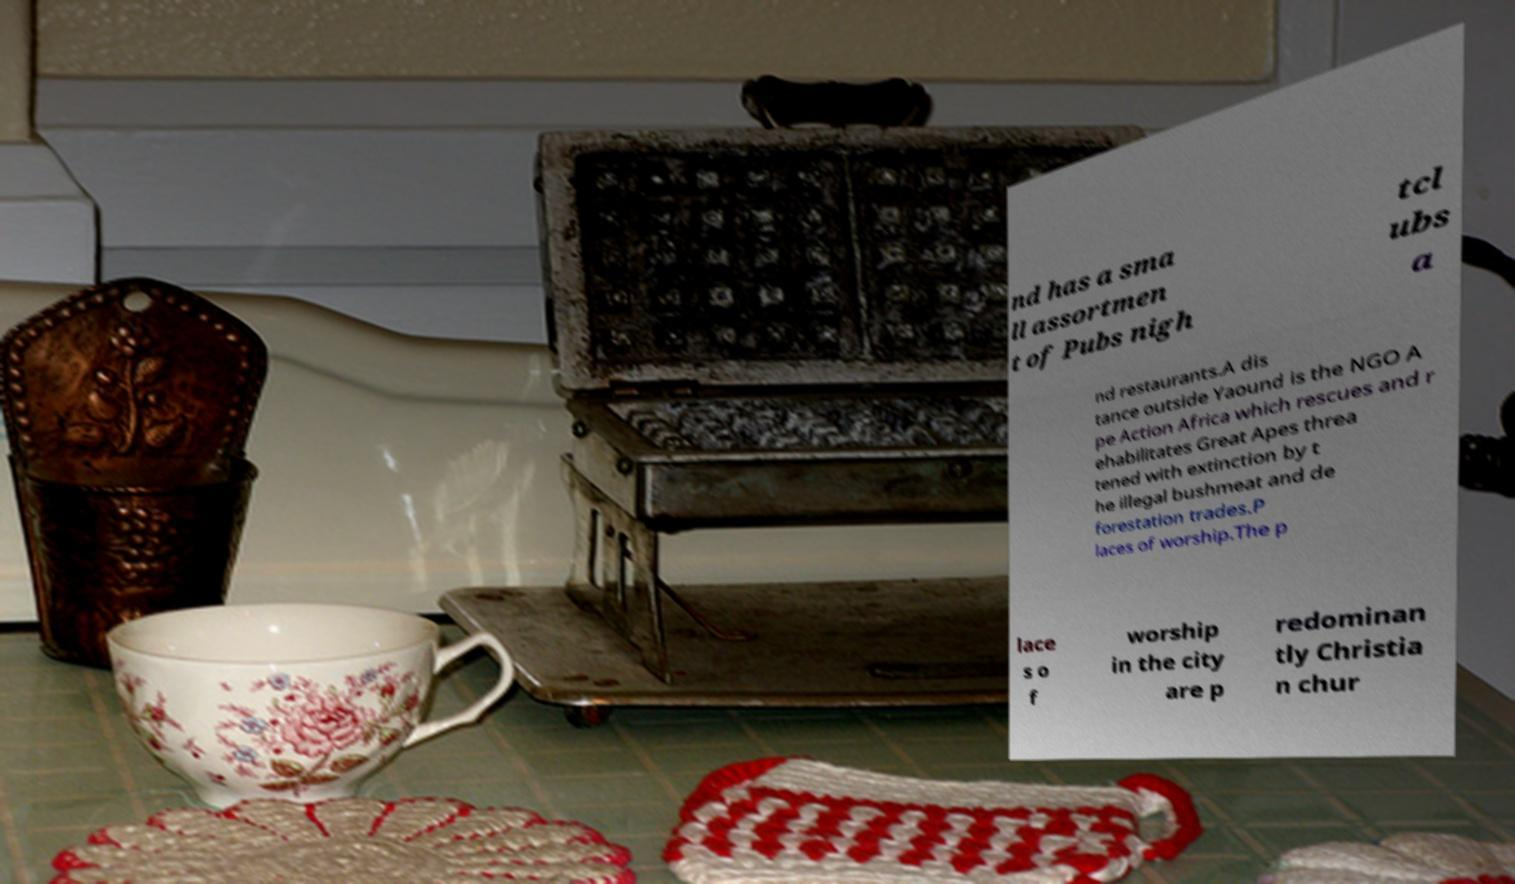For documentation purposes, I need the text within this image transcribed. Could you provide that? nd has a sma ll assortmen t of Pubs nigh tcl ubs a nd restaurants.A dis tance outside Yaound is the NGO A pe Action Africa which rescues and r ehabilitates Great Apes threa tened with extinction by t he illegal bushmeat and de forestation trades.P laces of worship.The p lace s o f worship in the city are p redominan tly Christia n chur 